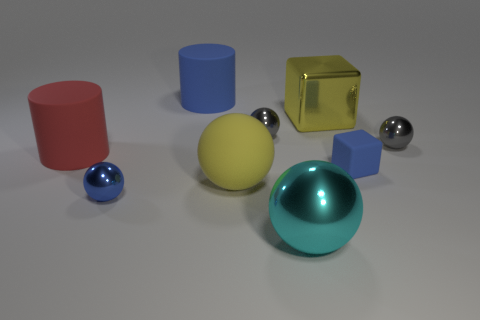There is a tiny blue thing that is to the left of the blue rubber cylinder; is its shape the same as the large blue thing?
Your answer should be compact. No. Is there a green rubber ball?
Provide a short and direct response. No. Is there any other thing that is the same shape as the large cyan object?
Give a very brief answer. Yes. Are there more big rubber things on the right side of the yellow sphere than large blue balls?
Offer a terse response. No. Are there any big matte cylinders behind the red rubber cylinder?
Your answer should be very brief. Yes. Is the size of the blue metallic object the same as the matte block?
Give a very brief answer. Yes. There is a cyan object that is the same shape as the large yellow matte object; what size is it?
Offer a very short reply. Large. What material is the tiny gray ball that is on the right side of the yellow thing that is behind the large yellow rubber thing?
Offer a terse response. Metal. Does the tiny blue metal object have the same shape as the big yellow rubber thing?
Make the answer very short. Yes. How many matte objects are in front of the big metallic cube and on the right side of the large red matte cylinder?
Your response must be concise. 2. 